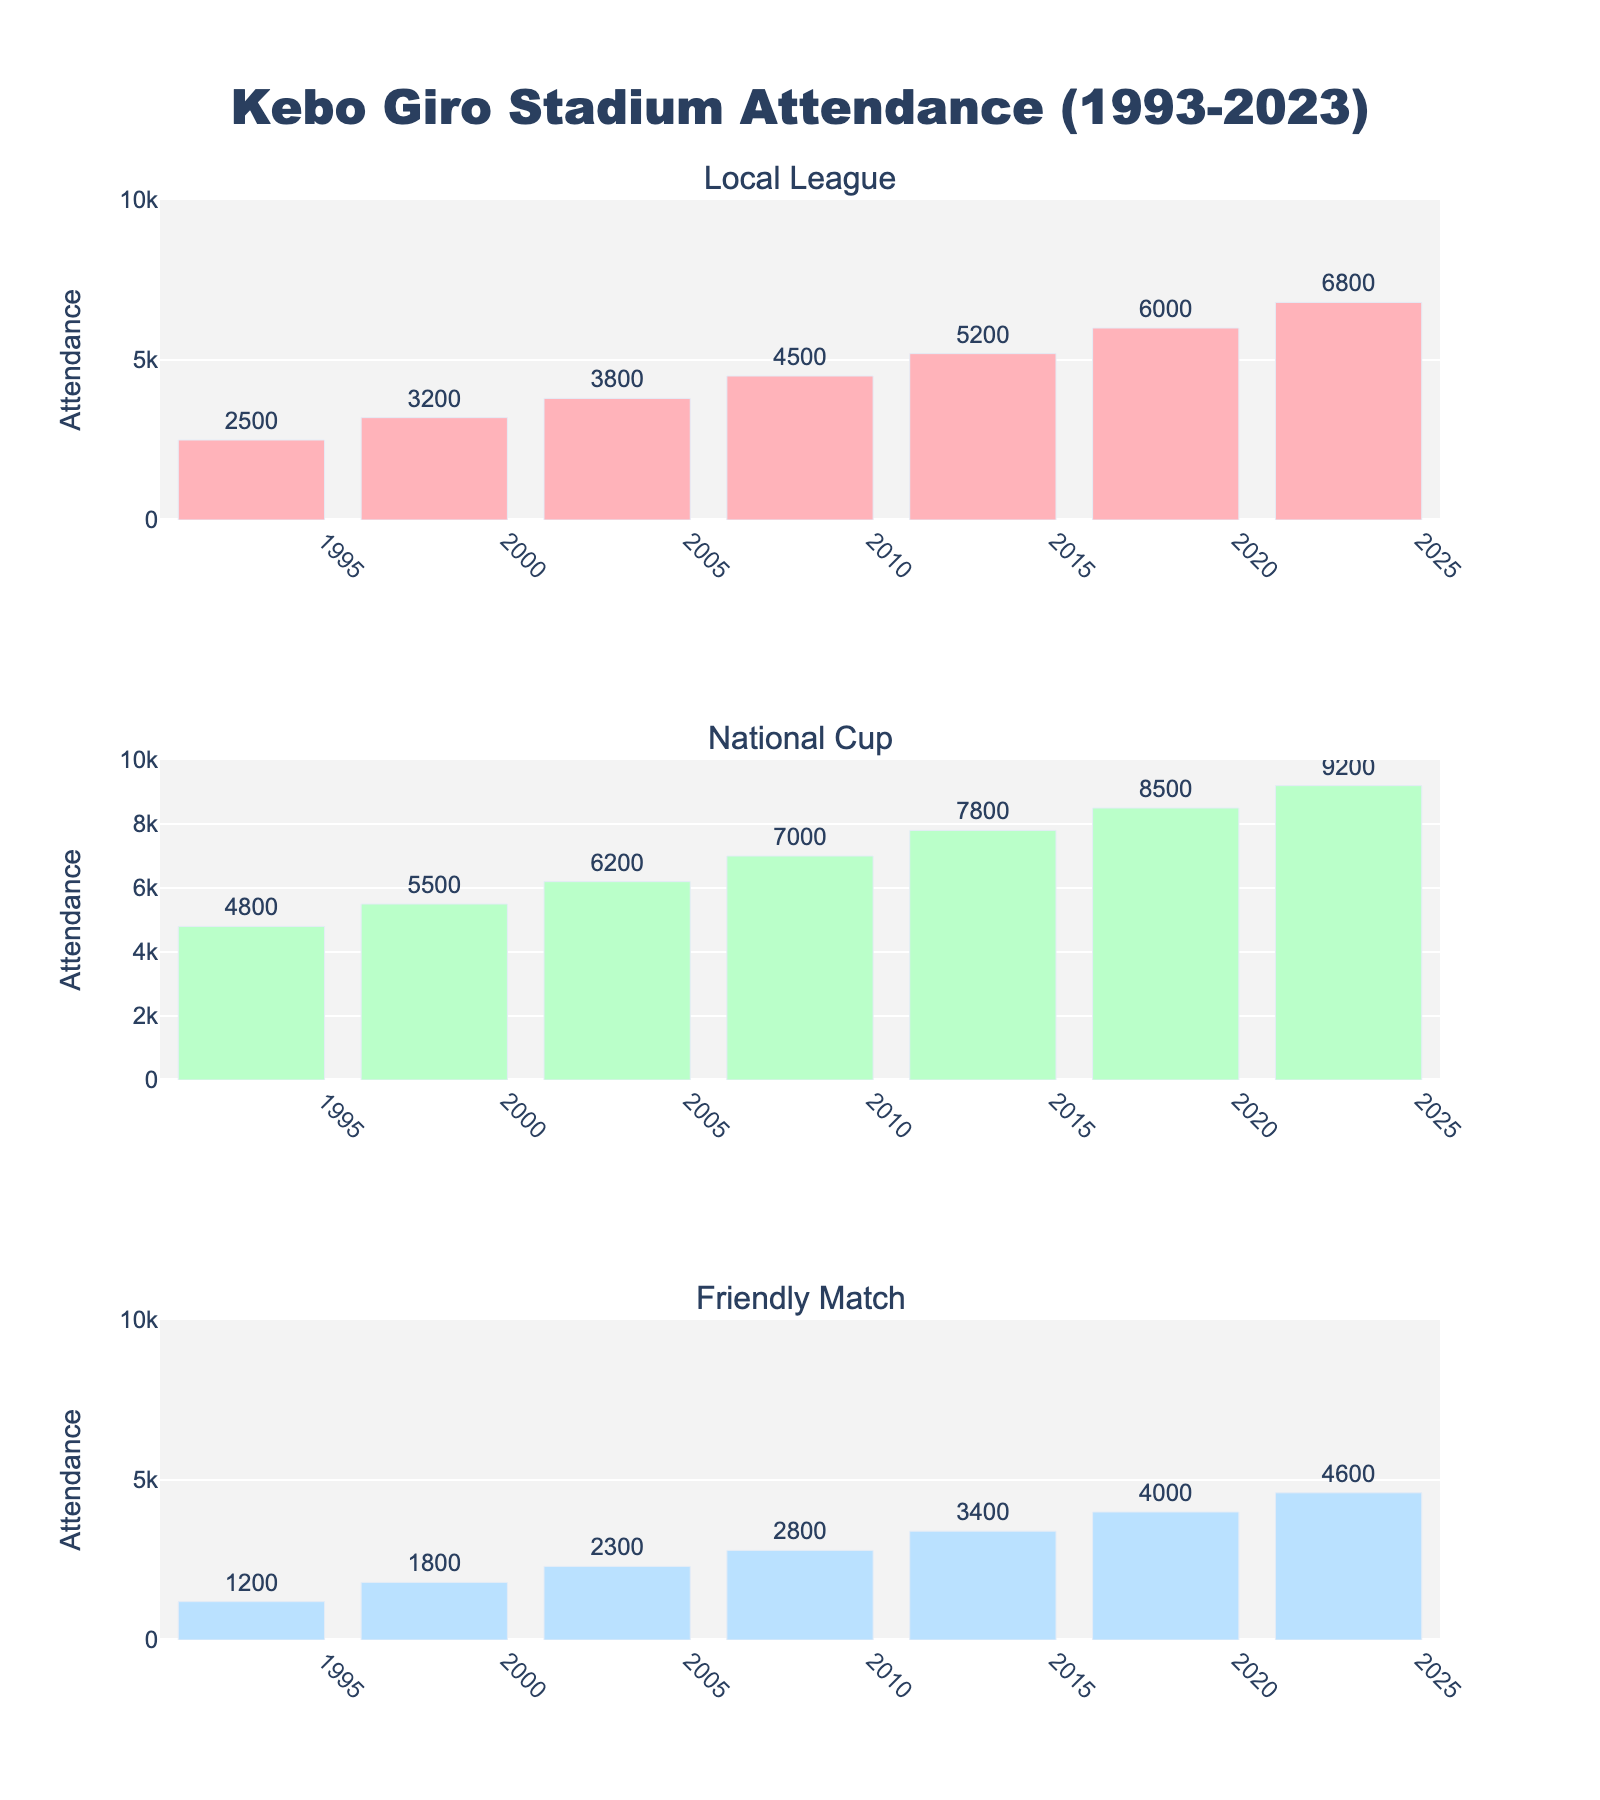What's the title of the figure? The title is usually located at the top of the figure in a larger font. Here, it reads "Kebo Giro Stadium Attendance (1993-2023)".
Answer: Kebo Giro Stadium Attendance (1993-2023) How many different football match types are displayed in the figure? The subplot titles list the types of football matches, which are "Local League", "National Cup", and "Friendly Match".
Answer: 3 Which year's National Cup match had the highest attendance? Looking at the "National Cup" subplot, the bar with the highest attendance is for the year 2023.
Answer: 2023 How does the attendance of Local League matches in 2018 compare to 2023? In the "Local League" subplot, the bar for 2018 is lower than the bar for 2023. The attendance increased from 6000 in 2018 to 6800 in 2023.
Answer: The attendance increased What is the difference in attendance between the National Cup and Friendly Match in 1998? In 1998, the National Cup attendance is 5500, and the Friendly Match attendance is 1800. Subtract the Friendly Match attendance from the National Cup attendance: 5500 - 1800 = 3700.
Answer: 3700 What's the average attendance for the Local League matches across all years? The attendance numbers for the Local League matches are 2500, 3200, 3800, 4500, 5200, 6000, and 6800. Sum these values: (2500 + 3200 + 3800 + 4500 + 5200 + 6000 + 6800) = 32000. Divide by the number of years: 32000 / 7 = 4571.43.
Answer: 4571.43 Which match type had the largest increase in attendance from 1993 to 2023? Compare the attendance for 1993 and 2023 in each subplot. The "National Cup" subplot shows the most considerable increase from 4800 in 1993 to 9200 in 2023. Calculate the increases: Local League: 6800 - 2500 = 4300, National Cup: 9200 - 4800 = 4400, Friendly Match: 4600 - 1200 = 3400.
Answer: National Cup What is the range of attendance in the Friendly Match subplot? The range is the difference between the highest and lowest attendance. The highest is 4600 (2023), and the lowest is 1200 (1993). Calculate the range: 4600 - 1200 = 3400.
Answer: 3400 